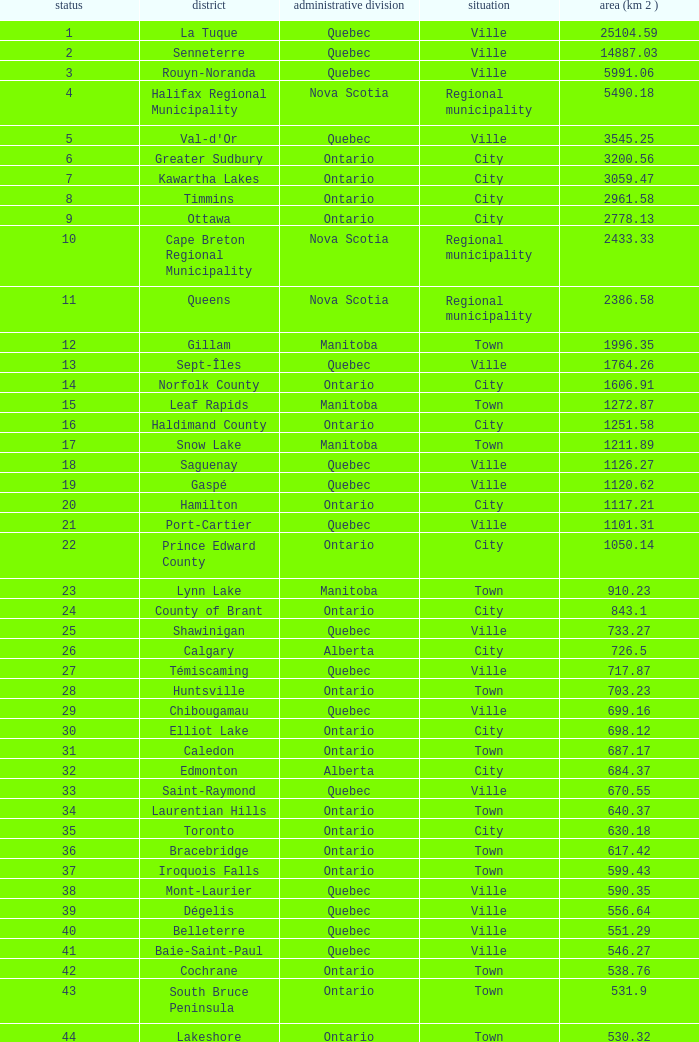What Municipality has a Rank of 44? Lakeshore. 